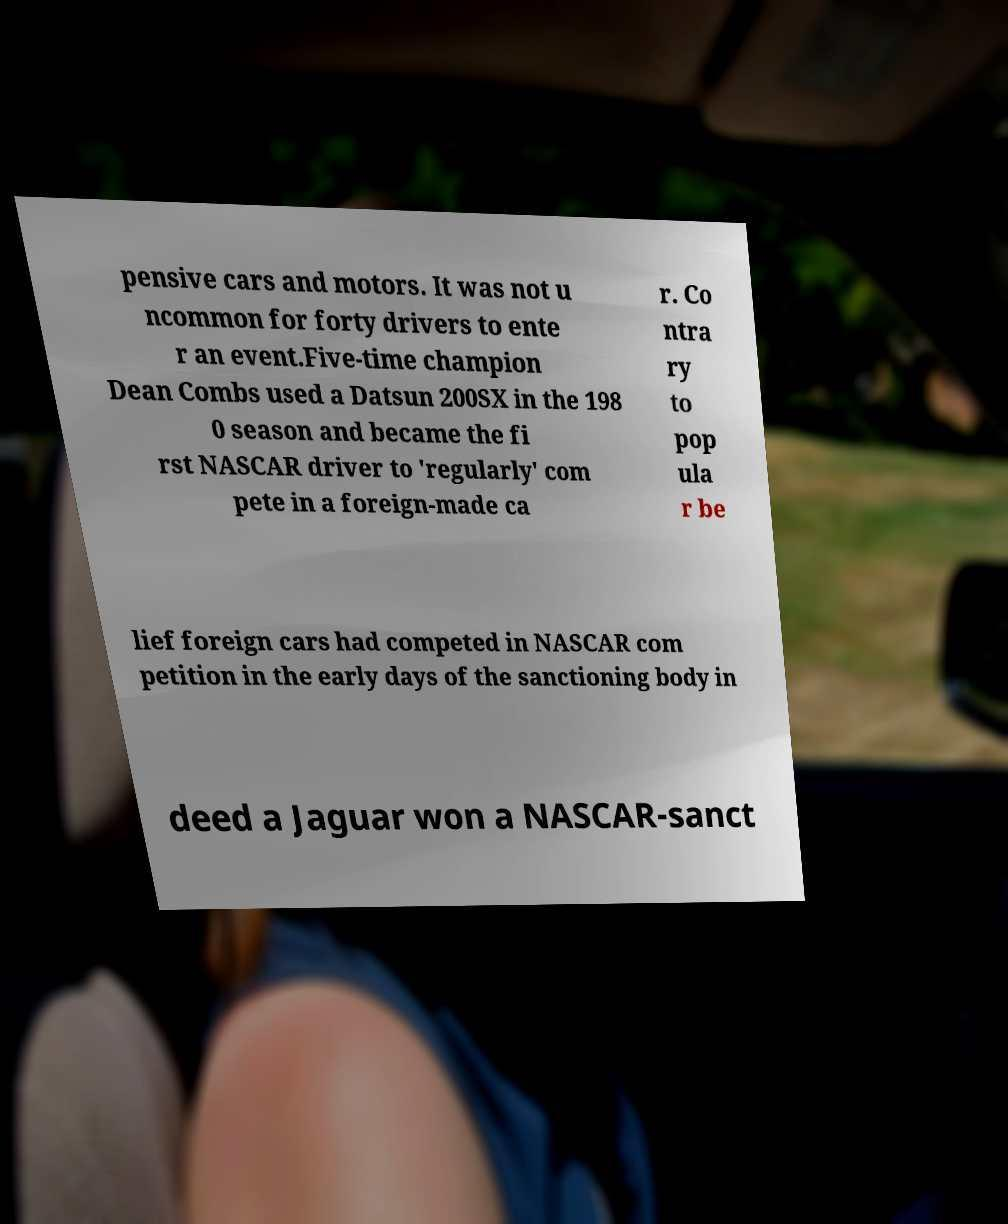There's text embedded in this image that I need extracted. Can you transcribe it verbatim? pensive cars and motors. It was not u ncommon for forty drivers to ente r an event.Five-time champion Dean Combs used a Datsun 200SX in the 198 0 season and became the fi rst NASCAR driver to 'regularly' com pete in a foreign-made ca r. Co ntra ry to pop ula r be lief foreign cars had competed in NASCAR com petition in the early days of the sanctioning body in deed a Jaguar won a NASCAR-sanct 